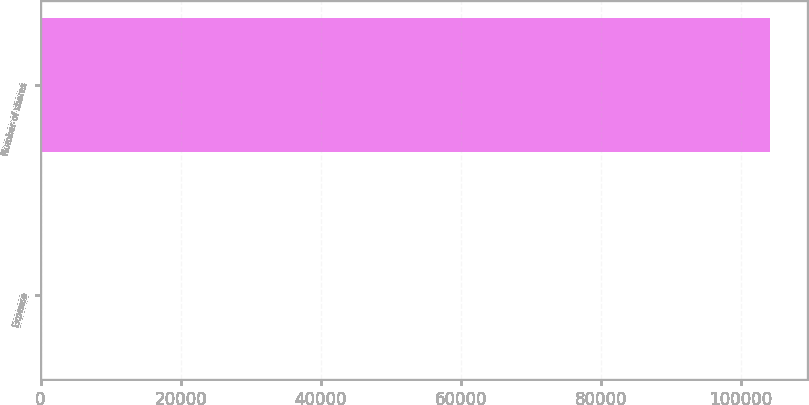<chart> <loc_0><loc_0><loc_500><loc_500><bar_chart><fcel>Expense<fcel>Number of shares<nl><fcel>23.9<fcel>104205<nl></chart> 